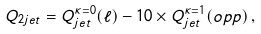<formula> <loc_0><loc_0><loc_500><loc_500>Q _ { 2 j e t } = Q _ { j e t } ^ { \kappa = 0 } ( \ell ) - 1 0 \times Q _ { j e t } ^ { \kappa = 1 } ( o p p ) \, ,</formula> 